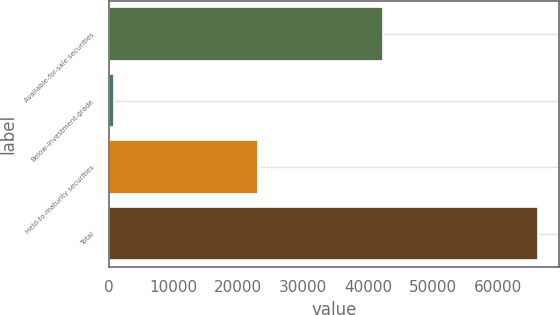Convert chart to OTSL. <chart><loc_0><loc_0><loc_500><loc_500><bar_chart><fcel>Available-for-sale securities<fcel>Below-investment-grade<fcel>Held-to-maturity securities<fcel>Total<nl><fcel>42273<fcel>786<fcel>23084<fcel>66143<nl></chart> 